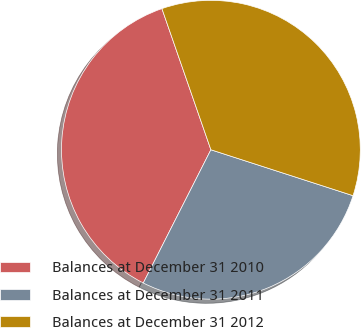<chart> <loc_0><loc_0><loc_500><loc_500><pie_chart><fcel>Balances at December 31 2010<fcel>Balances at December 31 2011<fcel>Balances at December 31 2012<nl><fcel>37.21%<fcel>27.5%<fcel>35.29%<nl></chart> 